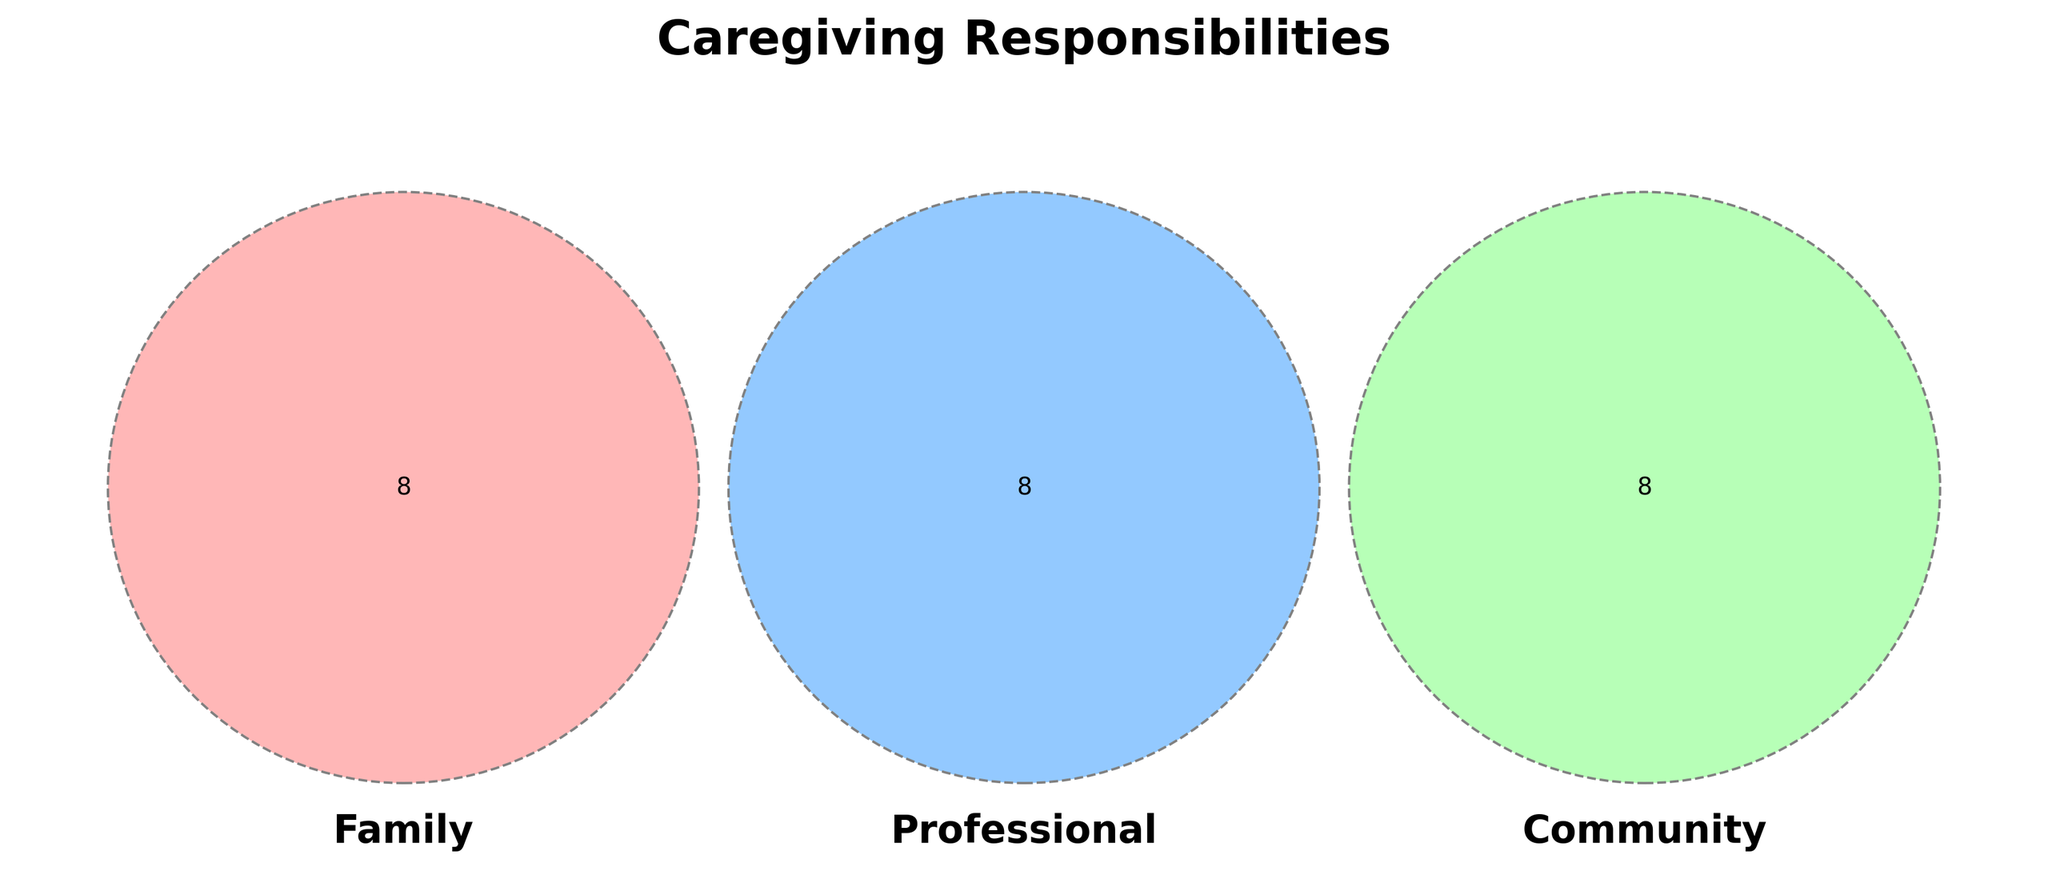What is the title of the Venn diagram? The title is usually displayed prominently above the diagram. The title helps in understanding the context of the Venn diagram.
Answer: Caregiving Responsibilities Which caregiving activities are only handled by family members? To find this, look at the section of the Venn diagram that only intersects with "Family" and lists activities contained there.
Answer: Medication management, Emotional support, Personal care assistance, Financial planning, Transportation, Meal preparation, Home modifications, Respite care Which caregiving activities are shared between family and professionals? Look at the section of the Venn diagram that intersects only between the "Family" and "Professional" circles without touching the "Community" circle.
Answer: No activities are listed in this section Which caregiving activities are handled by all three groups: family, professionals, and community? Find the section where all three circles intersect. This will show activities handled by all groups.
Answer: No activities are listed in this shared section Which group is responsible for intergenerational programs? Look into each circle for the exact activity. "Intergenerational programs" belong to "Community".
Answer: Community Compare the number of unique responsibilities handled by community vs professionals. Which group handles more? Count the sections exclusive to "Community" and "Professional" and compare. Community has 9 exclusive activities, Professional has 8. Therefore, Community handles more unique responsibilities.
Answer: Community Which unique caregiving activity shared between professionals and community but not by families? Check the intersecting section between "Professional" and "Community" while excluding "Family".
Answer: No activities are listed in this section Which caregiving activities involve healthcare specifically handled by professionals? Look at the "Professional" section for healthcare-related activities specifically.
Answer: Case management, Healthcare liaison, Discharge planning, Crisis intervention, Documentation, Care plan development, Resource referrals Are there any caregiving activities in common for family and community groups but not involving professionals? Look at the section shared by "Family" and "Community" excluding "Professional".
Answer: No activities are listed in this section Which caregiving activities are listed for professionals but not for families or communities? Look at the exclusive section for "Professional".
Answer: Case management, Healthcare liaison, Discharge planning, Resource referrals, Crisis intervention, Documentation, Team meetings, Care plan development 